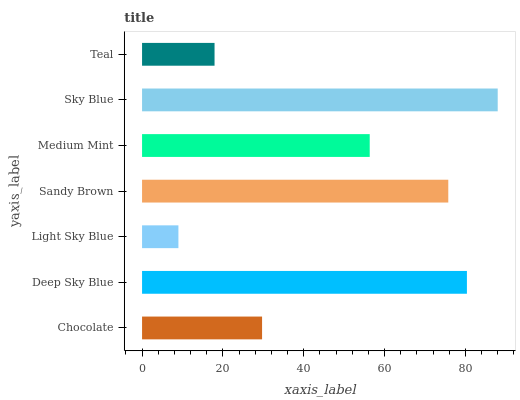Is Light Sky Blue the minimum?
Answer yes or no. Yes. Is Sky Blue the maximum?
Answer yes or no. Yes. Is Deep Sky Blue the minimum?
Answer yes or no. No. Is Deep Sky Blue the maximum?
Answer yes or no. No. Is Deep Sky Blue greater than Chocolate?
Answer yes or no. Yes. Is Chocolate less than Deep Sky Blue?
Answer yes or no. Yes. Is Chocolate greater than Deep Sky Blue?
Answer yes or no. No. Is Deep Sky Blue less than Chocolate?
Answer yes or no. No. Is Medium Mint the high median?
Answer yes or no. Yes. Is Medium Mint the low median?
Answer yes or no. Yes. Is Sandy Brown the high median?
Answer yes or no. No. Is Sky Blue the low median?
Answer yes or no. No. 